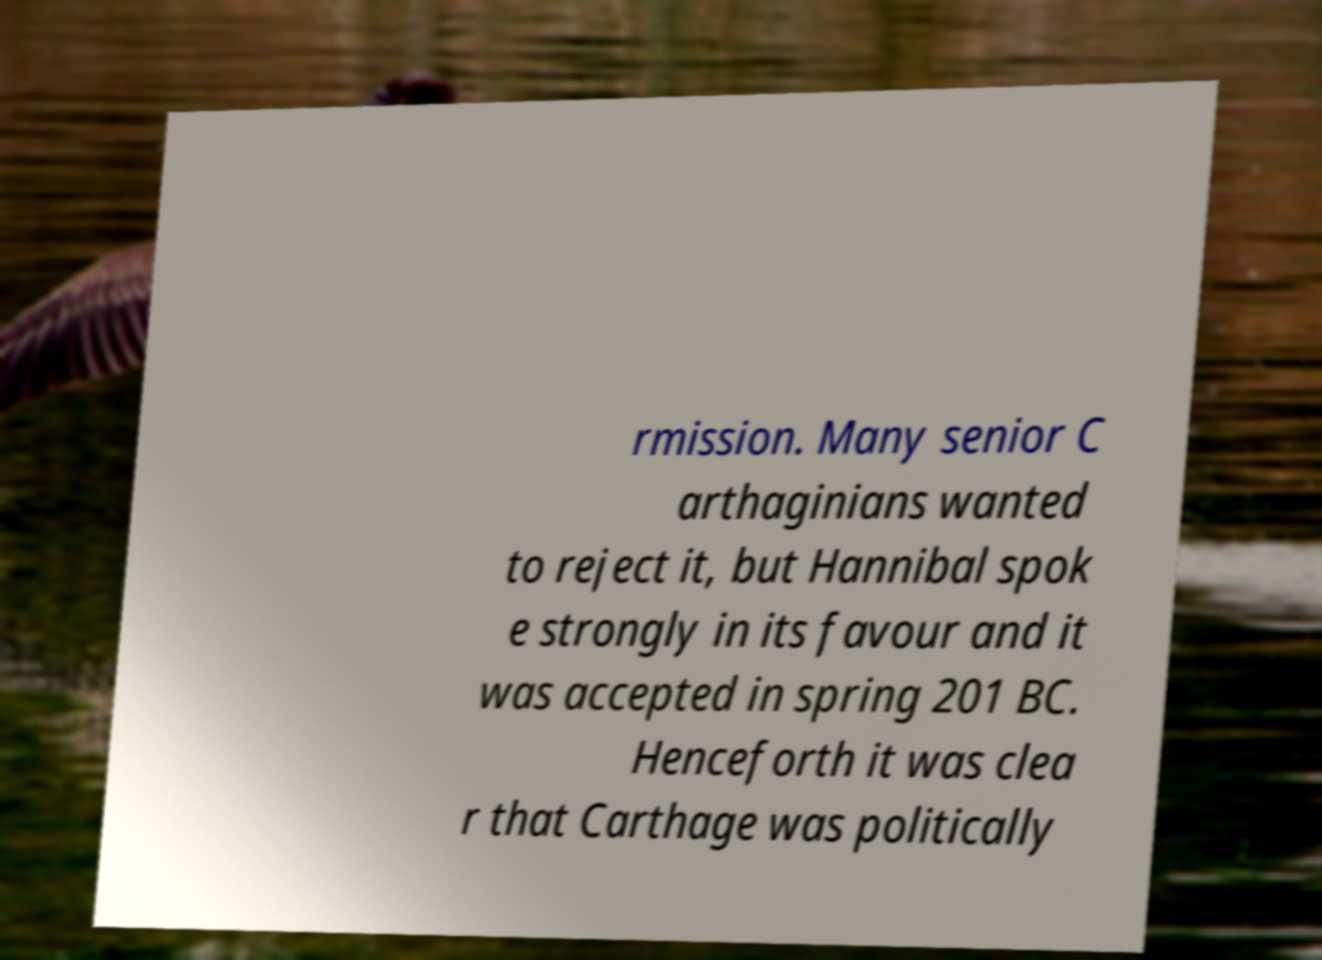Can you read and provide the text displayed in the image?This photo seems to have some interesting text. Can you extract and type it out for me? rmission. Many senior C arthaginians wanted to reject it, but Hannibal spok e strongly in its favour and it was accepted in spring 201 BC. Henceforth it was clea r that Carthage was politically 